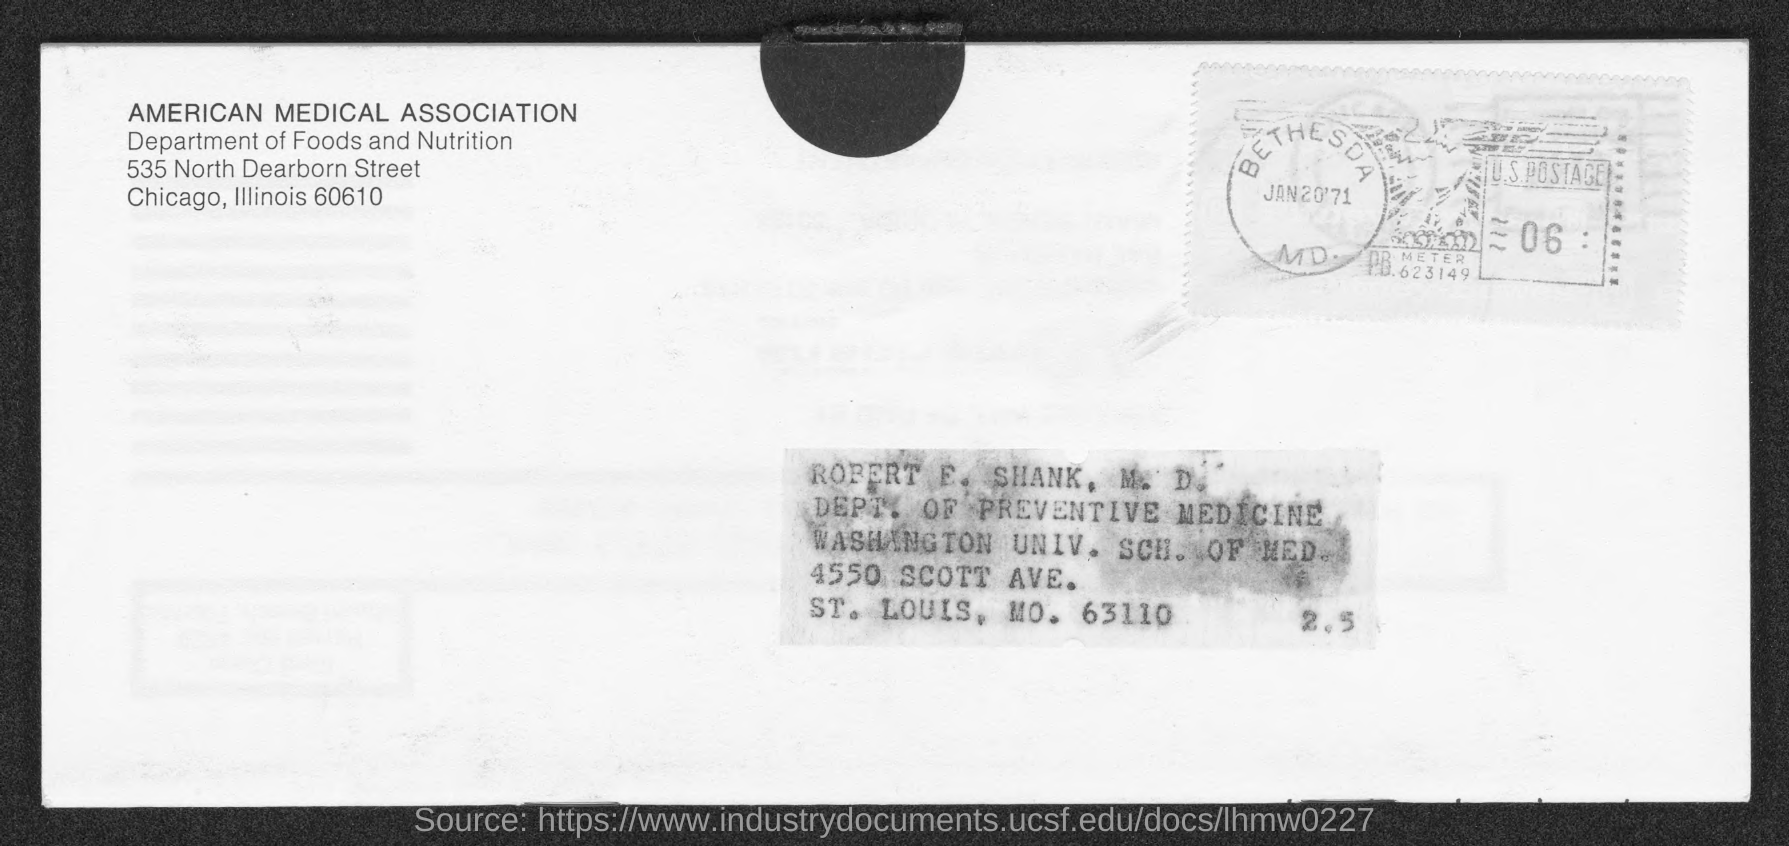Point out several critical features in this image. The date on the seal is January 20th, 1971. 